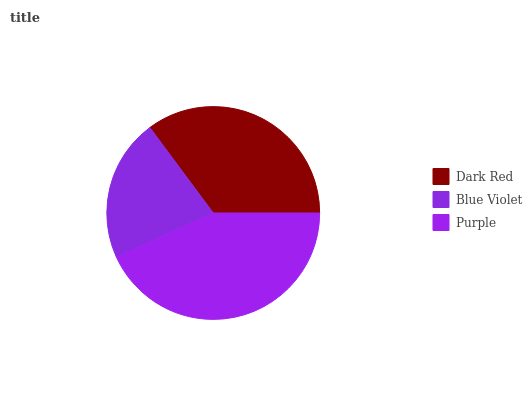Is Blue Violet the minimum?
Answer yes or no. Yes. Is Purple the maximum?
Answer yes or no. Yes. Is Purple the minimum?
Answer yes or no. No. Is Blue Violet the maximum?
Answer yes or no. No. Is Purple greater than Blue Violet?
Answer yes or no. Yes. Is Blue Violet less than Purple?
Answer yes or no. Yes. Is Blue Violet greater than Purple?
Answer yes or no. No. Is Purple less than Blue Violet?
Answer yes or no. No. Is Dark Red the high median?
Answer yes or no. Yes. Is Dark Red the low median?
Answer yes or no. Yes. Is Purple the high median?
Answer yes or no. No. Is Purple the low median?
Answer yes or no. No. 